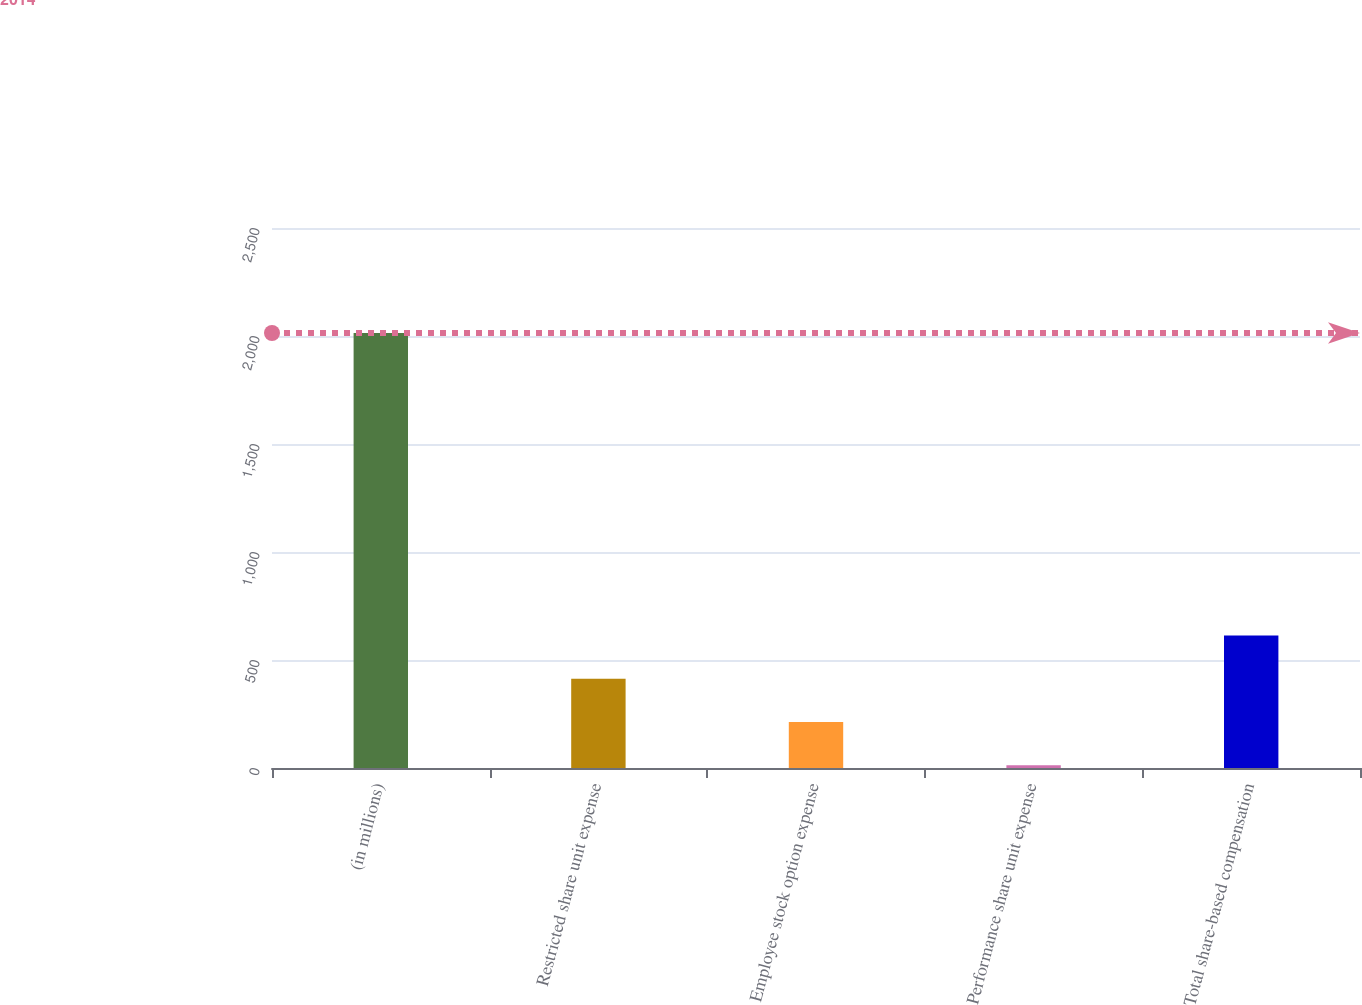Convert chart. <chart><loc_0><loc_0><loc_500><loc_500><bar_chart><fcel>(in millions)<fcel>Restricted share unit expense<fcel>Employee stock option expense<fcel>Performance share unit expense<fcel>Total share-based compensation<nl><fcel>2014<fcel>413.2<fcel>213.1<fcel>13<fcel>613.3<nl></chart> 